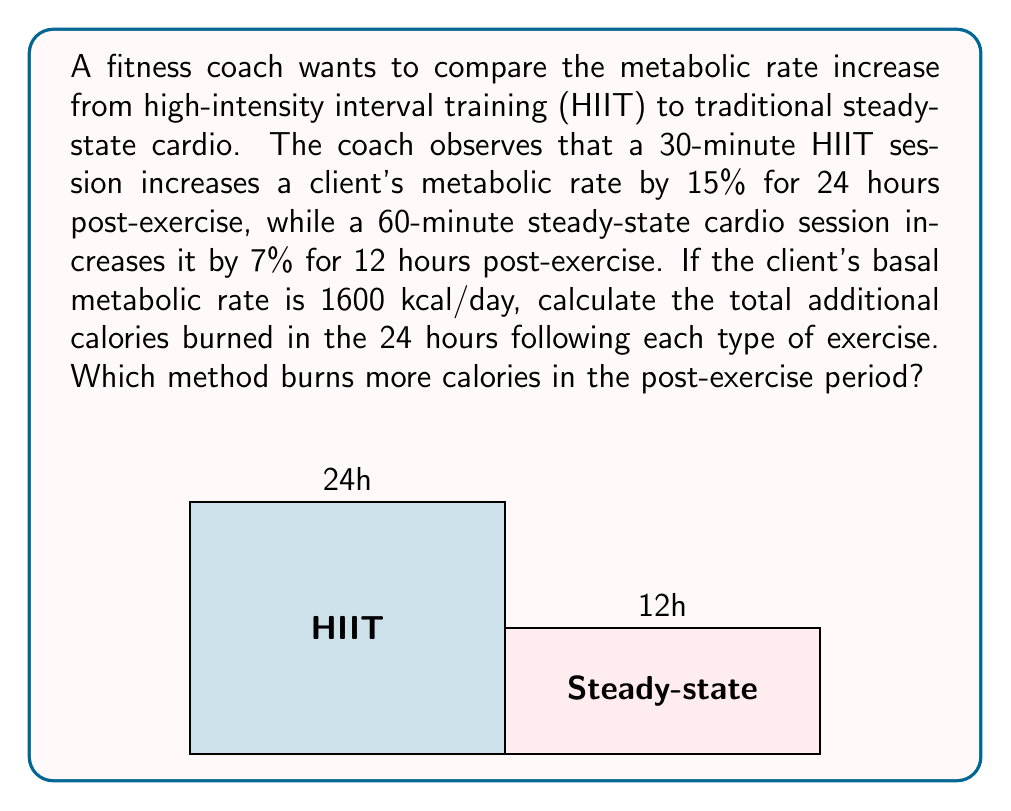Can you solve this math problem? Let's approach this step-by-step:

1) First, let's calculate the additional calories burned after HIIT:
   - Basal metabolic rate (BMR) = 1600 kcal/day
   - Increase = 15% = 0.15
   - Duration = 24 hours
   
   Additional calories = BMR * Increase * Duration
   $$\text{HIIT}_\text{additional} = 1600 * 0.15 * 1 = 240 \text{ kcal}$$

2) Now, let's calculate for steady-state cardio:
   - BMR = 1600 kcal/day
   - Increase = 7% = 0.07
   - Duration = 12 hours = 0.5 days
   
   $$\text{Steady}_\text{additional} = 1600 * 0.07 * 0.5 = 56 \text{ kcal}$$

3) Compare the results:
   HIIT burns 240 kcal additionally in 24 hours
   Steady-state burns 56 kcal additionally in 12 hours, which we need to double for a fair 24-hour comparison:
   $$56 * 2 = 112 \text{ kcal}$$

Therefore, HIIT burns more calories (240 kcal) in the post-exercise period compared to steady-state cardio (112 kcal) over 24 hours.
Answer: HIIT burns 240 kcal, steady-state burns 112 kcal; HIIT is more effective. 